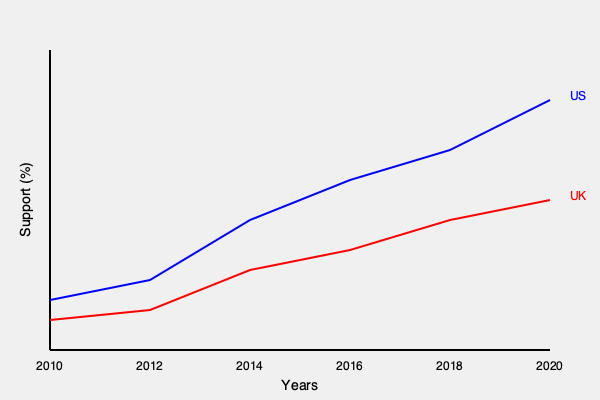Based on the infographic showing public support for universal healthcare in the US and UK from 2010 to 2020, what is the approximate difference in percentage points between US and UK support in 2020? To find the difference in percentage points between US and UK support for universal healthcare in 2020:

1. Locate the data points for 2020 (rightmost on the x-axis).
2. Estimate the y-axis values for both countries:
   - US (blue line): approximately 75%
   - UK (red line): approximately 60%
3. Calculate the difference:
   75% - 60% = 15 percentage points

The US shows a steeper increase in support over time, while the UK's support grows more gradually. This reflects changing attitudes in the US towards healthcare reform, possibly influenced by political debates and international comparisons.
Answer: 15 percentage points 